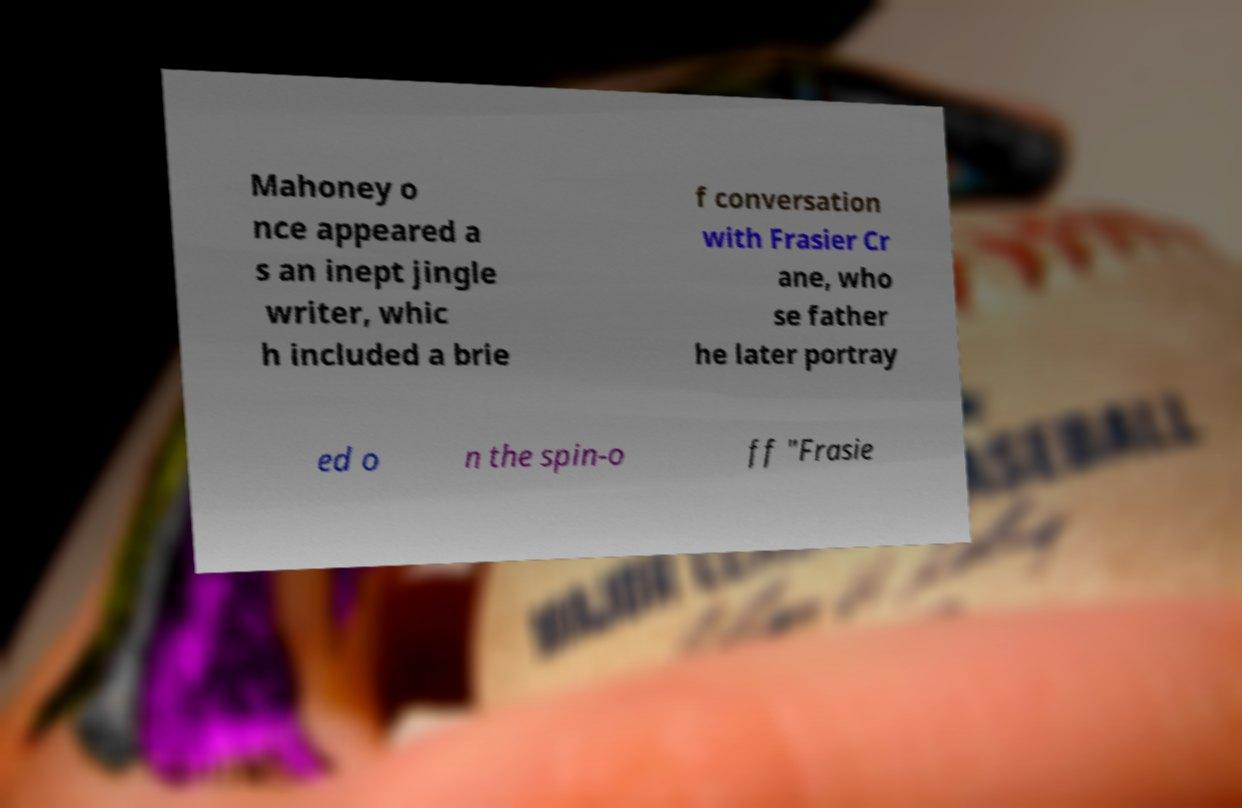There's text embedded in this image that I need extracted. Can you transcribe it verbatim? Mahoney o nce appeared a s an inept jingle writer, whic h included a brie f conversation with Frasier Cr ane, who se father he later portray ed o n the spin-o ff "Frasie 